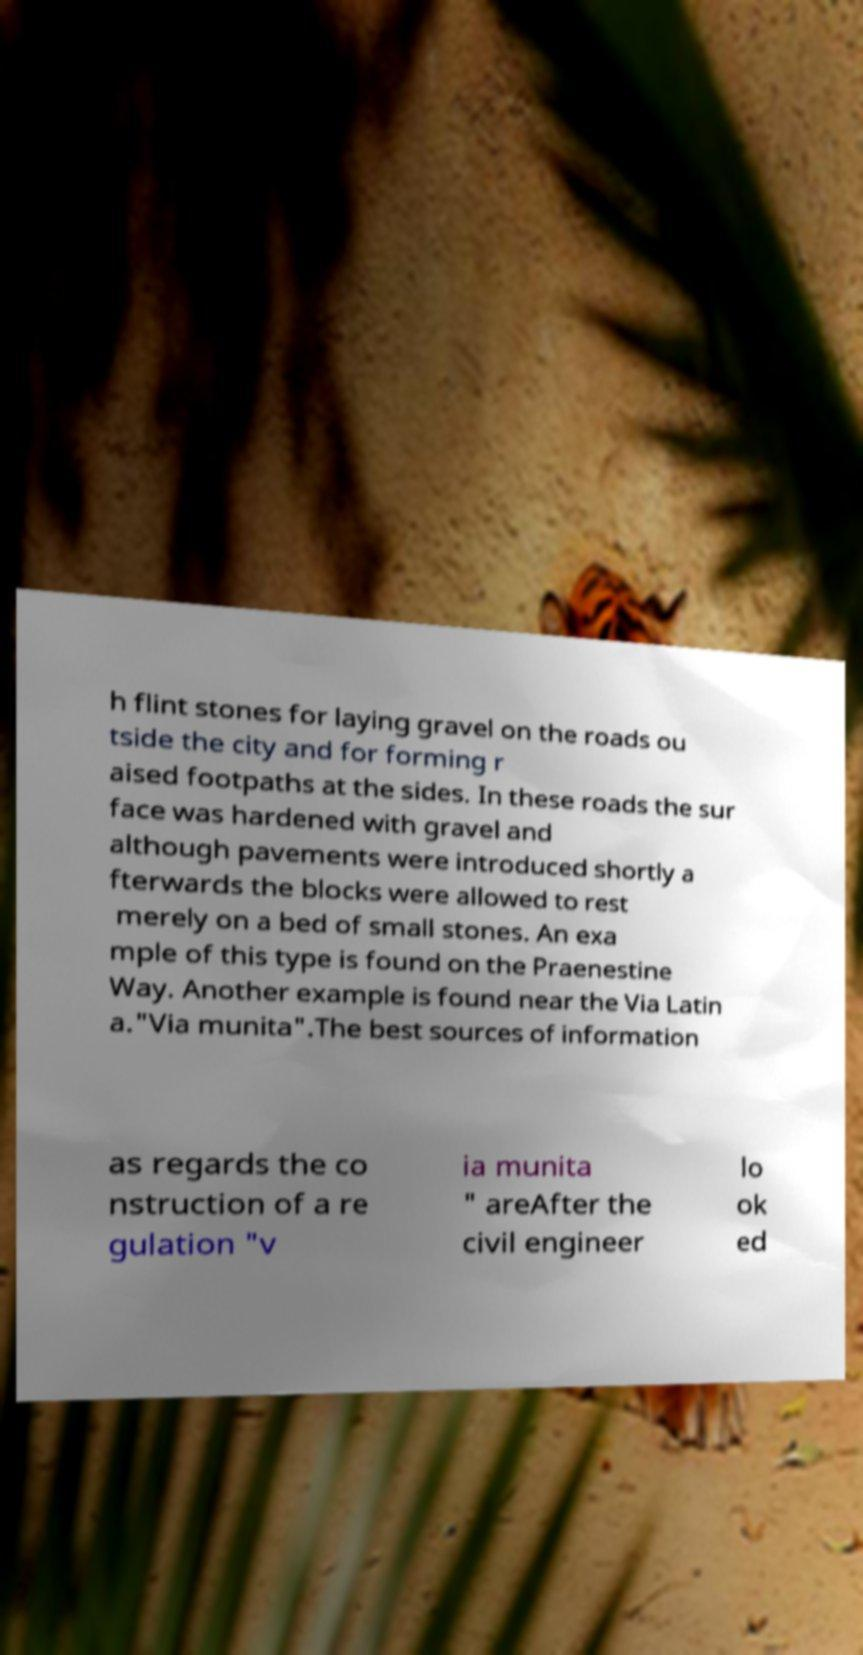For documentation purposes, I need the text within this image transcribed. Could you provide that? h flint stones for laying gravel on the roads ou tside the city and for forming r aised footpaths at the sides. In these roads the sur face was hardened with gravel and although pavements were introduced shortly a fterwards the blocks were allowed to rest merely on a bed of small stones. An exa mple of this type is found on the Praenestine Way. Another example is found near the Via Latin a."Via munita".The best sources of information as regards the co nstruction of a re gulation "v ia munita " areAfter the civil engineer lo ok ed 